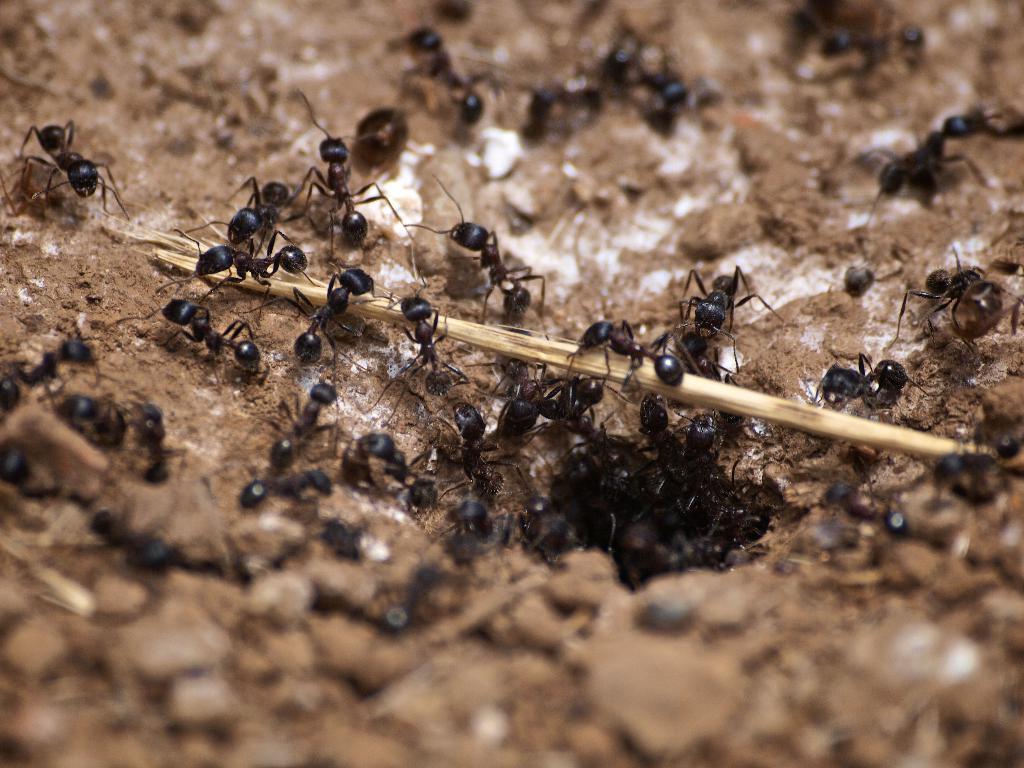Could you give a brief overview of what you see in this image? In the image there are many black ants on the sand surface. 